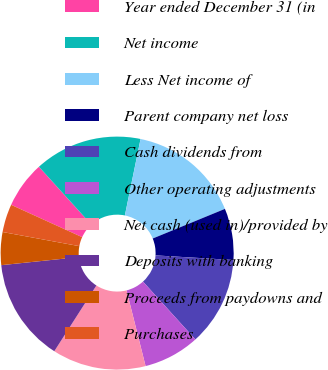Convert chart. <chart><loc_0><loc_0><loc_500><loc_500><pie_chart><fcel>Year ended December 31 (in<fcel>Net income<fcel>Less Net income of<fcel>Parent company net loss<fcel>Cash dividends from<fcel>Other operating adjustments<fcel>Net cash (used in)/provided by<fcel>Deposits with banking<fcel>Proceeds from paydowns and<fcel>Purchases<nl><fcel>6.49%<fcel>14.93%<fcel>15.58%<fcel>7.14%<fcel>12.34%<fcel>7.79%<fcel>12.99%<fcel>14.28%<fcel>4.55%<fcel>3.9%<nl></chart> 